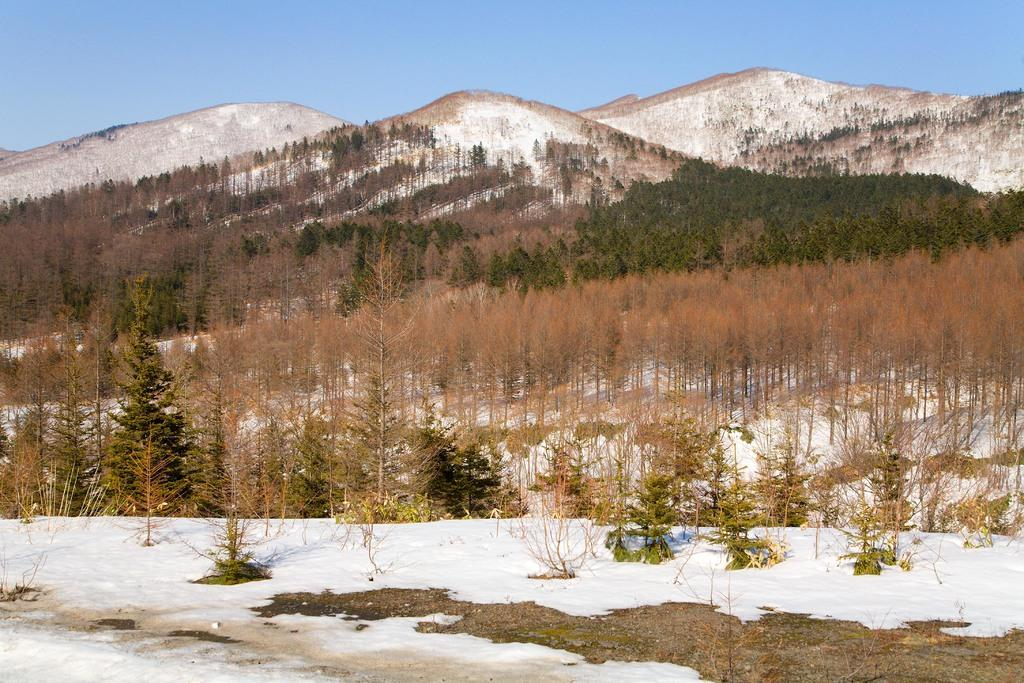What is the primary weather condition depicted in the image? There is snow in the image. What type of natural environment is shown in the image? There are trees and hills in the image. What is the girl's interest in the image? There is no girl present in the image. 